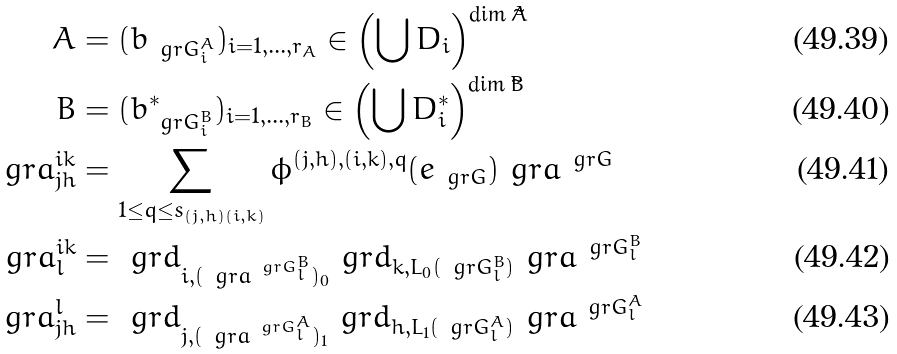Convert formula to latex. <formula><loc_0><loc_0><loc_500><loc_500>A & = ( b _ { \ g r G ^ { A } _ { i } } ) _ { i = 1 , \dots , r _ { A } } \in \left ( \bigcup D _ { i } \right ) ^ { \dim \tilde { A } } \\ B & = ( b ^ { * } _ { \ g r G ^ { B } _ { i } } ) _ { i = 1 , \dots , r _ { B } } \in \left ( \bigcup D ^ { * } _ { i } \right ) ^ { \dim \tilde { B } } \\ \ g r a ^ { i k } _ { j h } & = \sum _ { 1 \leq q \leq s _ { ( j , h ) ( i , k ) } } \phi ^ { ( j , h ) , ( i , k ) , q } ( e _ { \ g r G } ) \ g r a ^ { \ g r G } \\ \ g r a ^ { i k } _ { l } & = \ g r d _ { i , ( \ g r a ^ { \ g r G ^ { B } _ { l } } ) _ { 0 } } \ g r d _ { k , L _ { 0 } ( \ g r G ^ { B } _ { l } ) } \ g r a ^ { \ g r G ^ { B } _ { l } } \\ \ g r a _ { j h } ^ { l } & = \ g r d _ { j , ( \ g r a ^ { \ g r G ^ { A } _ { l } } ) _ { 1 } } \ g r d _ { h , L _ { 1 } ( \ g r G ^ { A } _ { l } ) } \ g r a ^ { \ g r G ^ { A } _ { l } }</formula> 